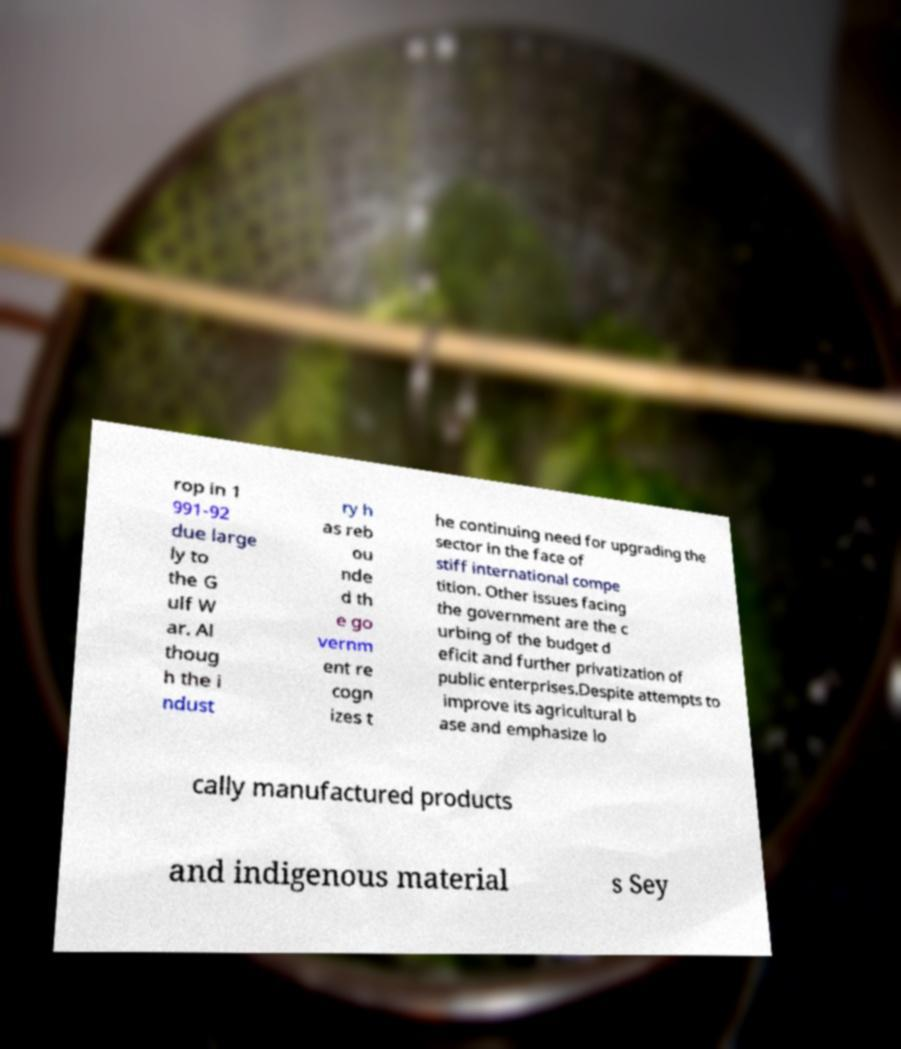What messages or text are displayed in this image? I need them in a readable, typed format. rop in 1 991-92 due large ly to the G ulf W ar. Al thoug h the i ndust ry h as reb ou nde d th e go vernm ent re cogn izes t he continuing need for upgrading the sector in the face of stiff international compe tition. Other issues facing the government are the c urbing of the budget d eficit and further privatization of public enterprises.Despite attempts to improve its agricultural b ase and emphasize lo cally manufactured products and indigenous material s Sey 